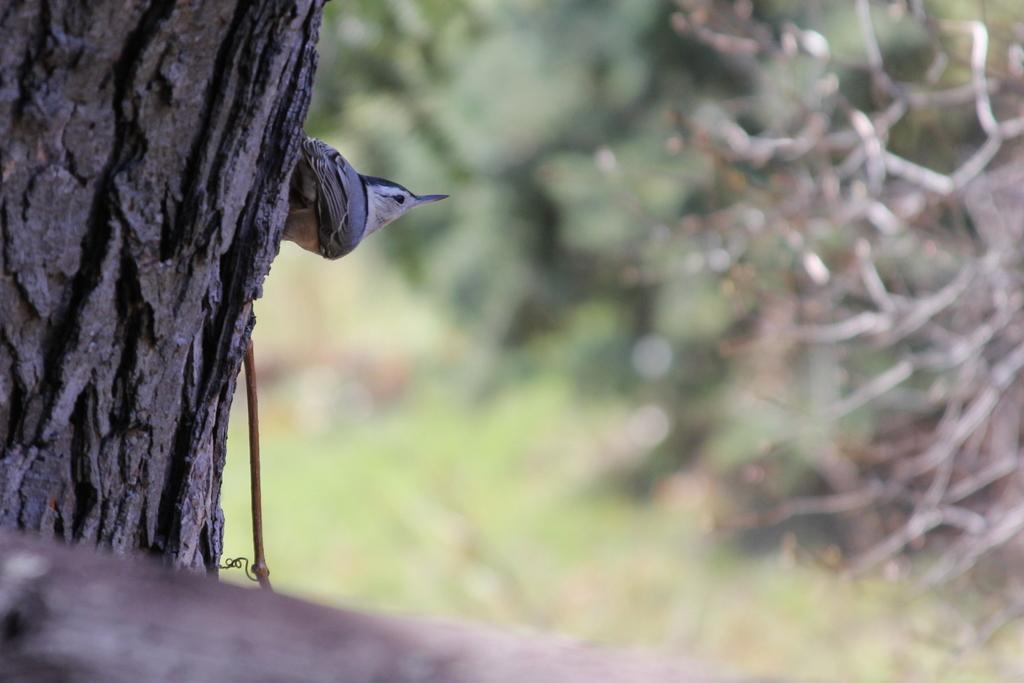Can you describe this image briefly? In this image on the left side we can see a tree trunk and a bird. In the background the image is blur but we can see plants. At the bottom there is an object. 